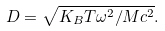<formula> <loc_0><loc_0><loc_500><loc_500>D = \sqrt { K _ { B } T { \omega } ^ { 2 } / M c ^ { 2 } } .</formula> 